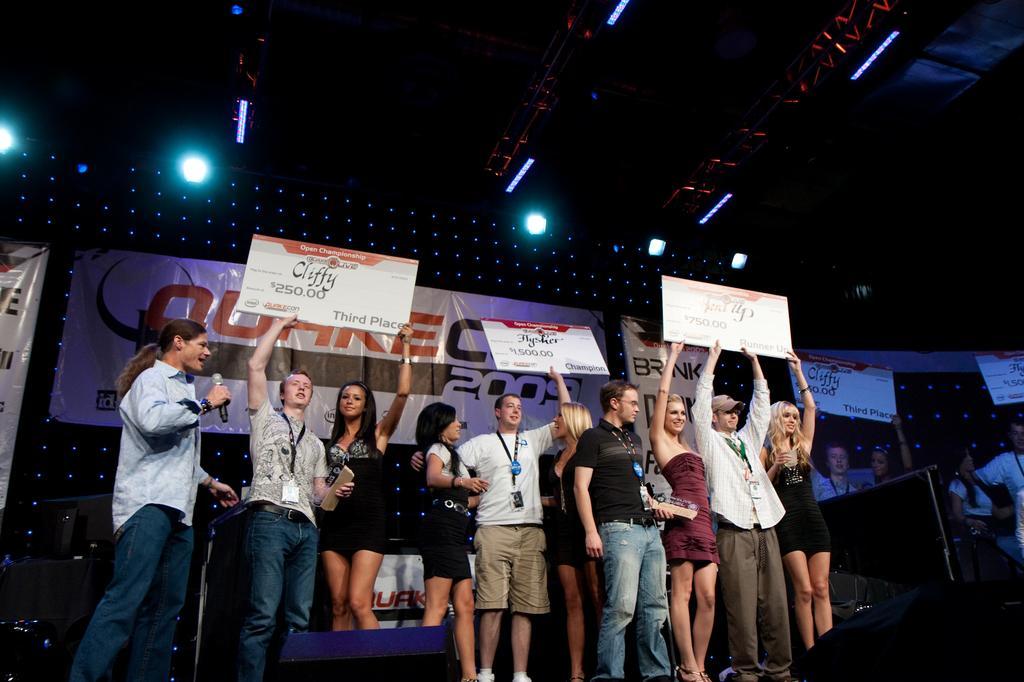How would you summarize this image in a sentence or two? In this image we can see these people are standing on the stage and holding boards. In the background, we can see the banners and we can see the show lights, here we can see the projector screen. 